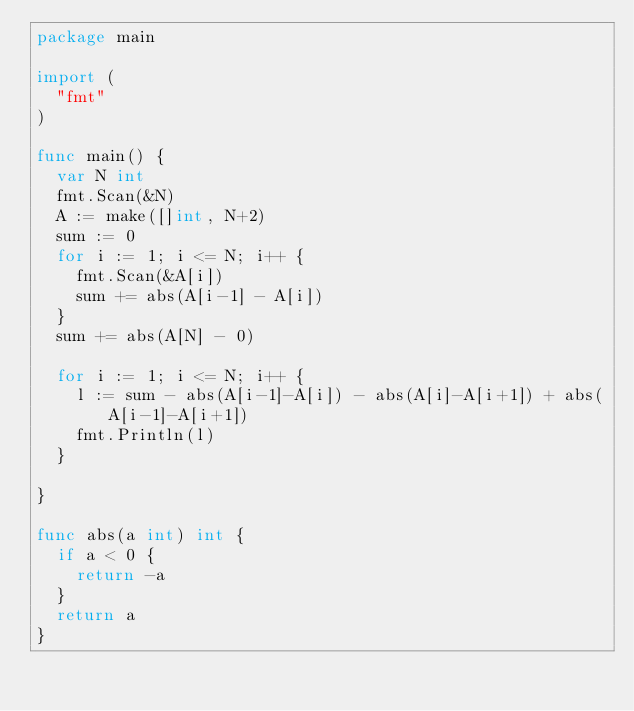<code> <loc_0><loc_0><loc_500><loc_500><_Go_>package main

import (
	"fmt"
)

func main() {
	var N int
	fmt.Scan(&N)
	A := make([]int, N+2)
	sum := 0
	for i := 1; i <= N; i++ {
		fmt.Scan(&A[i])
		sum += abs(A[i-1] - A[i])
	}
	sum += abs(A[N] - 0)

	for i := 1; i <= N; i++ {
		l := sum - abs(A[i-1]-A[i]) - abs(A[i]-A[i+1]) + abs(A[i-1]-A[i+1])
		fmt.Println(l)
	}

}

func abs(a int) int {
	if a < 0 {
		return -a
	}
	return a
}
</code> 